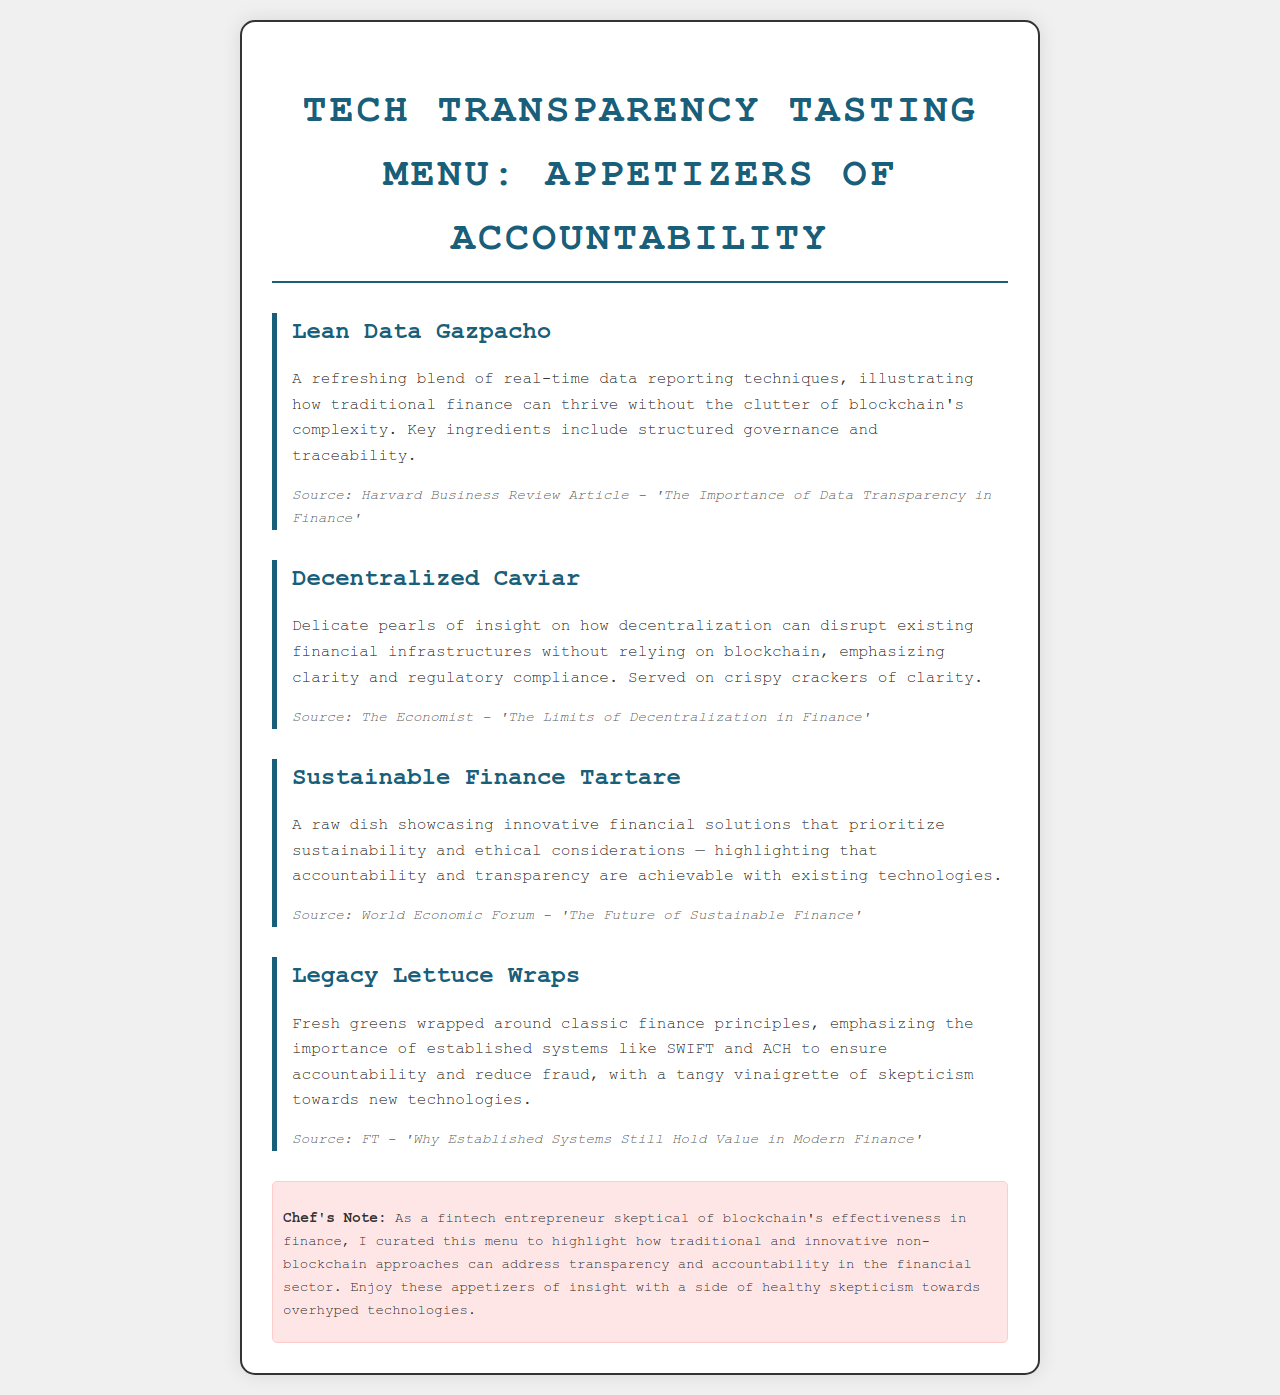What is the title of the menu? The title of the menu is presented at the top of the document, providing the theme of the offerings.
Answer: Tech Transparency Tasting Menu: Appetizers of Accountability What is the first appetizer listed? The first appetizer appears in the initial section of the menu, showcasing a culinary creation.
Answer: Lean Data Gazpacho Which publication is cited for the Sustainable Finance Tartare? The citation for this dish refers to an authoritative source that discusses sustainable finance.
Answer: World Economic Forum - 'The Future of Sustainable Finance' What key ingredient is mentioned in the Lean Data Gazpacho? This appetizer focuses on specific themes relevant to data in finance, highlighting an important aspect.
Answer: real-time data reporting techniques What type of dish is Decentralized Caviar served on? The description of this dish includes details about its presentation, enhancing its appeal.
Answer: crispy crackers of clarity What is emphasized in the Legacy Lettuce Wraps? The details of this appetizer focus on traditional finance principles as a central theme.
Answer: established systems like SWIFT and ACH What is the source of the information for the Decentralized Caviar? The document attributes insights about this dish to a specific publication discussing decentralization.
Answer: The Economist - 'The Limits of Decentralization in Finance' What is the Chef's Note's perspective on blockchain technologies? The note provides an outlook on the Chef's views regarding modern financial technologies.
Answer: skepticism towards overhyped technologies What is the overall theme of the appetizers? The menu's offerings center around a significant focus within the financial sector, critiquing certain trends.
Answer: accountability and transparency 